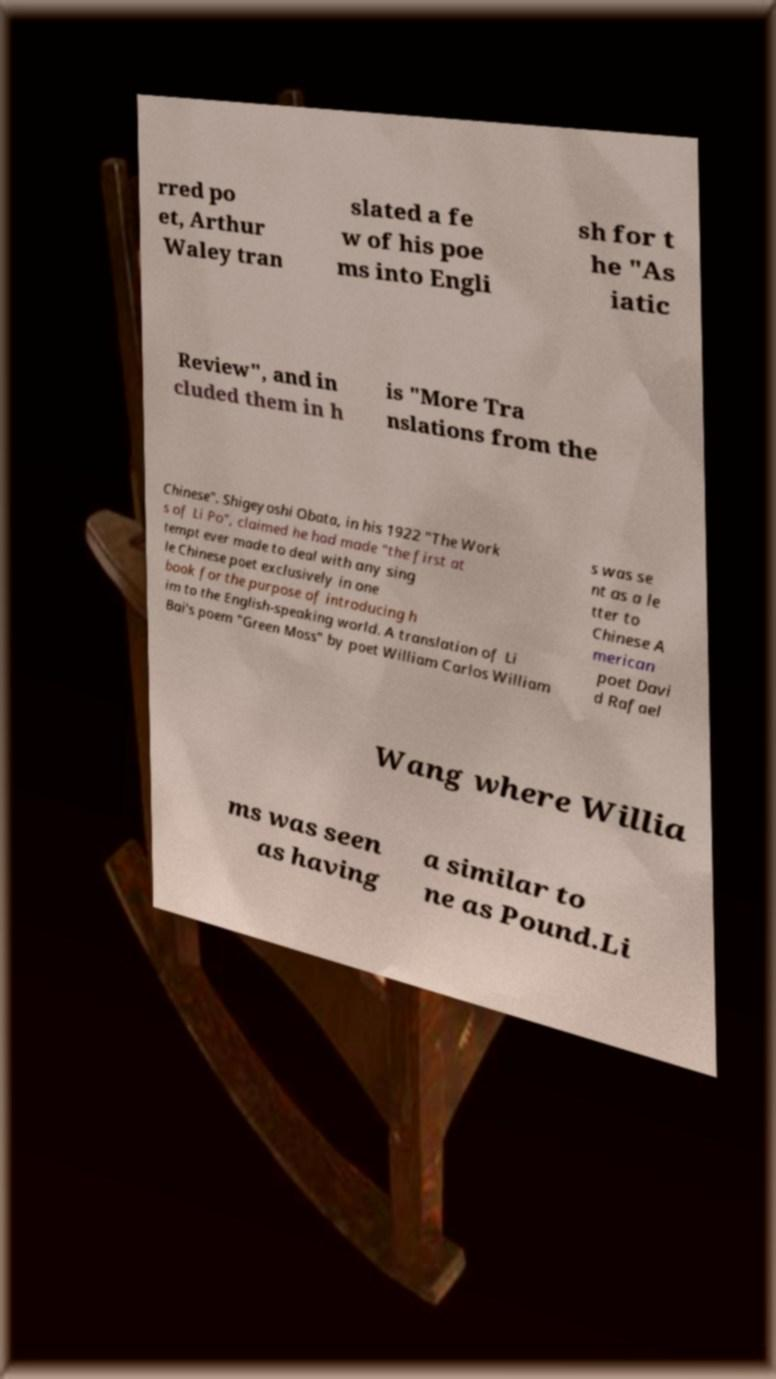I need the written content from this picture converted into text. Can you do that? rred po et, Arthur Waley tran slated a fe w of his poe ms into Engli sh for t he "As iatic Review", and in cluded them in h is "More Tra nslations from the Chinese". Shigeyoshi Obata, in his 1922 "The Work s of Li Po", claimed he had made "the first at tempt ever made to deal with any sing le Chinese poet exclusively in one book for the purpose of introducing h im to the English-speaking world. A translation of Li Bai's poem "Green Moss" by poet William Carlos William s was se nt as a le tter to Chinese A merican poet Davi d Rafael Wang where Willia ms was seen as having a similar to ne as Pound.Li 